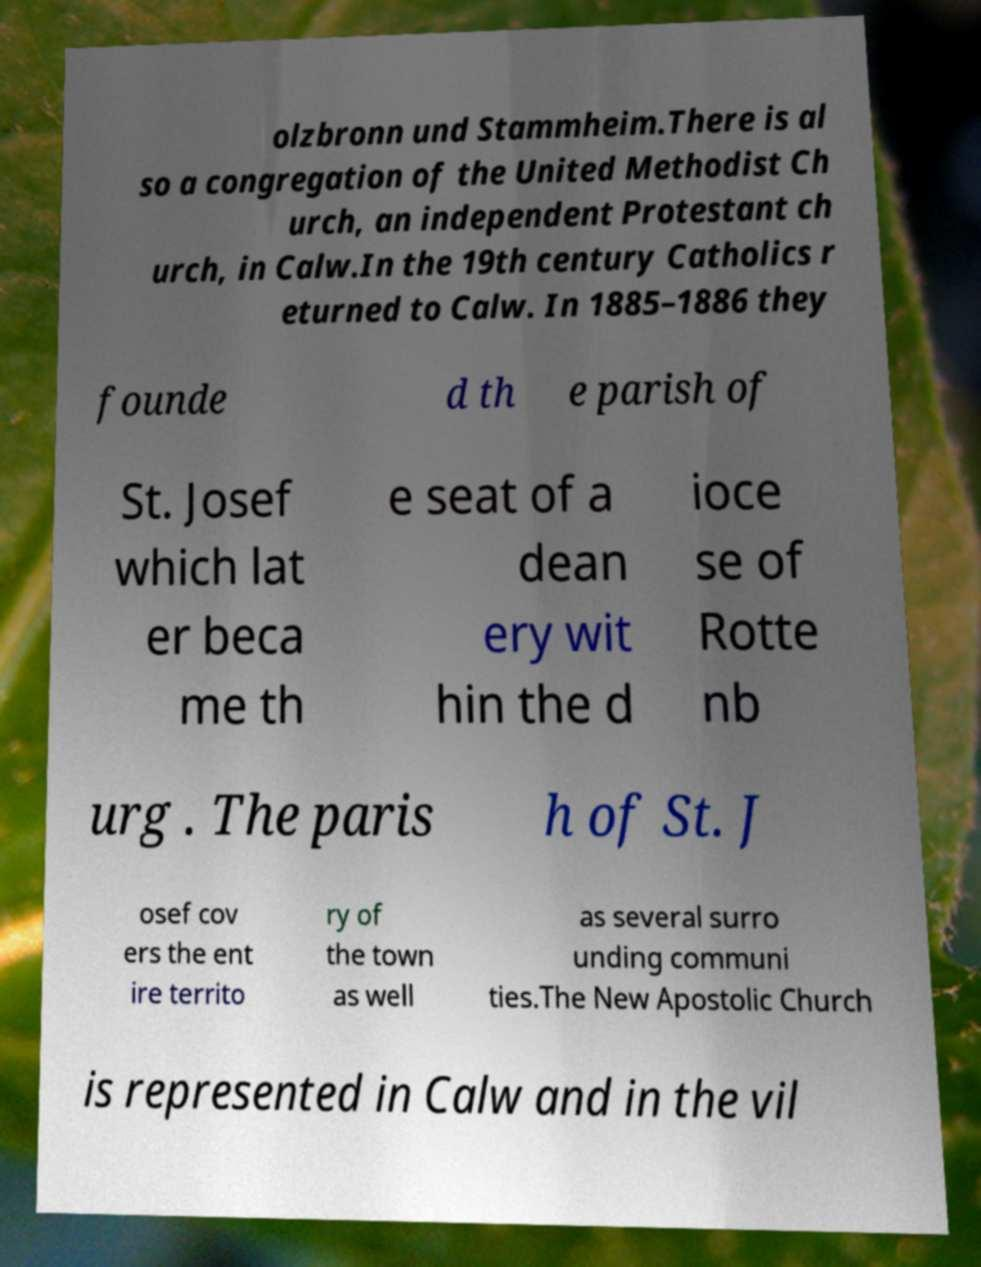For documentation purposes, I need the text within this image transcribed. Could you provide that? olzbronn und Stammheim.There is al so a congregation of the United Methodist Ch urch, an independent Protestant ch urch, in Calw.In the 19th century Catholics r eturned to Calw. In 1885–1886 they founde d th e parish of St. Josef which lat er beca me th e seat of a dean ery wit hin the d ioce se of Rotte nb urg . The paris h of St. J osef cov ers the ent ire territo ry of the town as well as several surro unding communi ties.The New Apostolic Church is represented in Calw and in the vil 